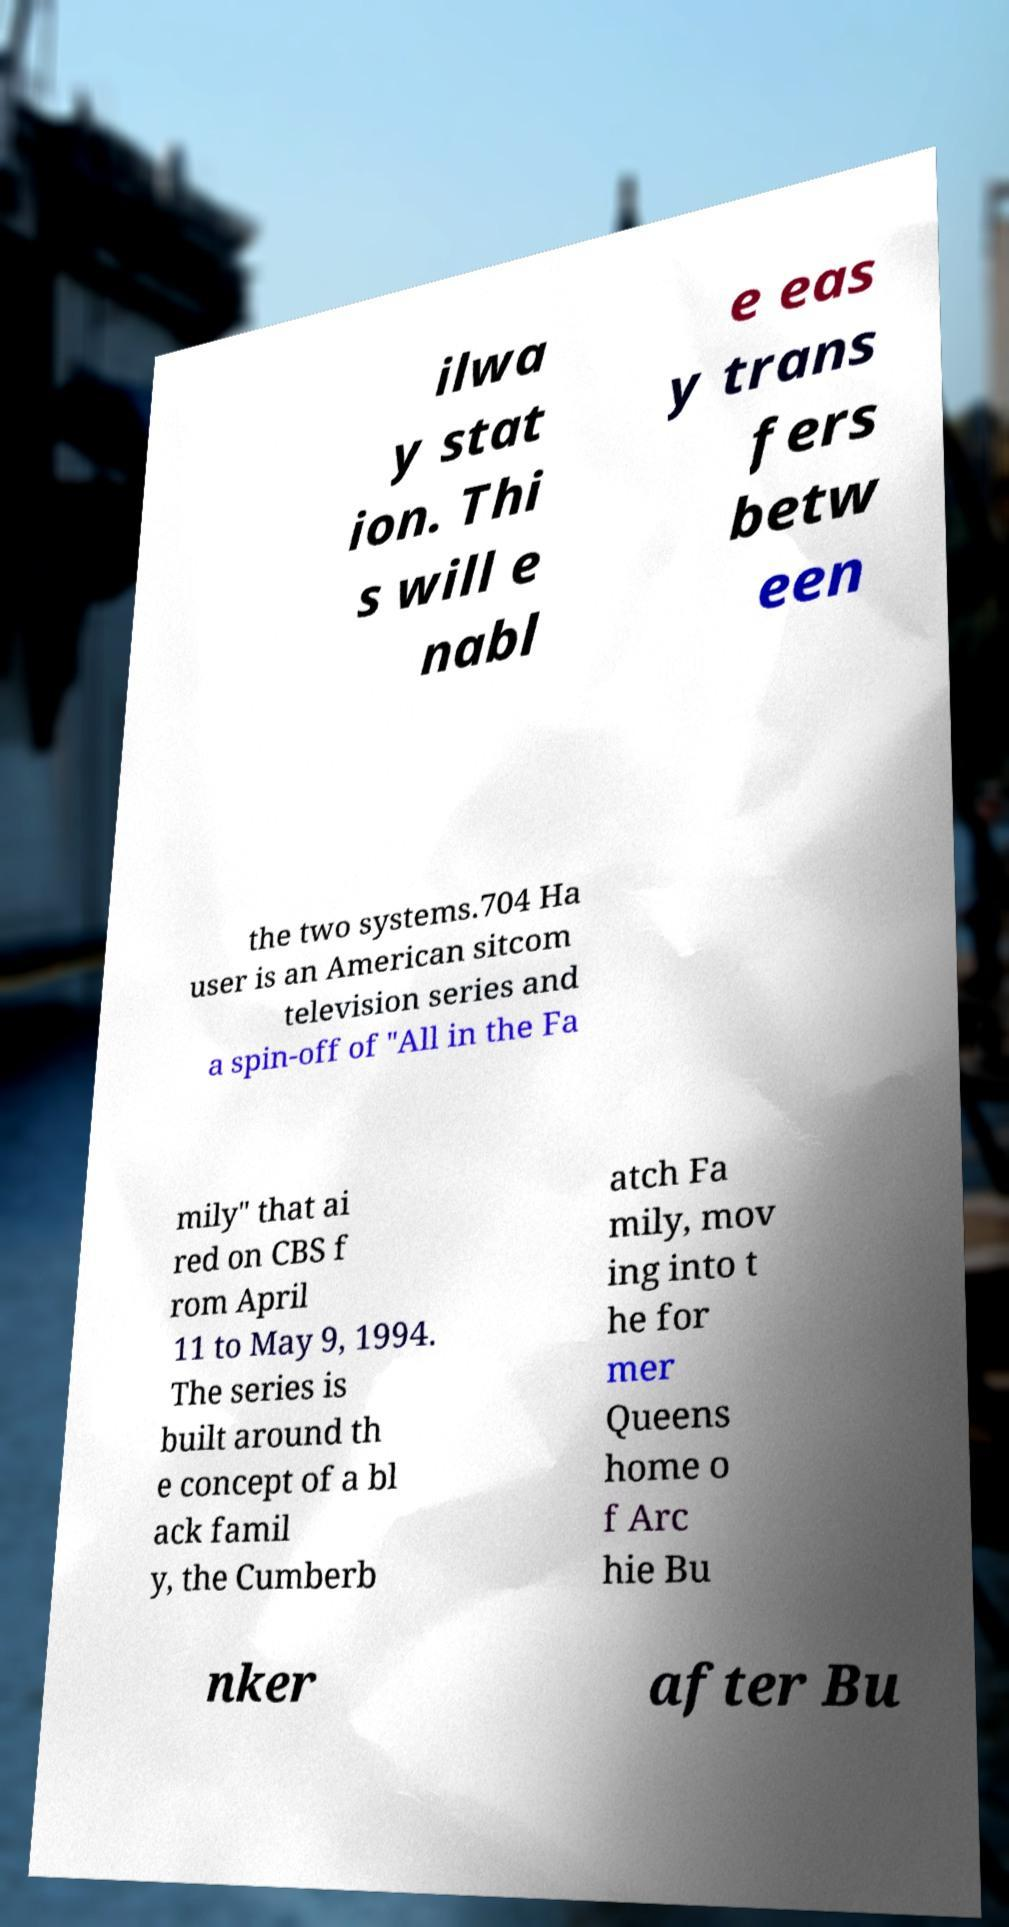Can you accurately transcribe the text from the provided image for me? ilwa y stat ion. Thi s will e nabl e eas y trans fers betw een the two systems.704 Ha user is an American sitcom television series and a spin-off of "All in the Fa mily" that ai red on CBS f rom April 11 to May 9, 1994. The series is built around th e concept of a bl ack famil y, the Cumberb atch Fa mily, mov ing into t he for mer Queens home o f Arc hie Bu nker after Bu 